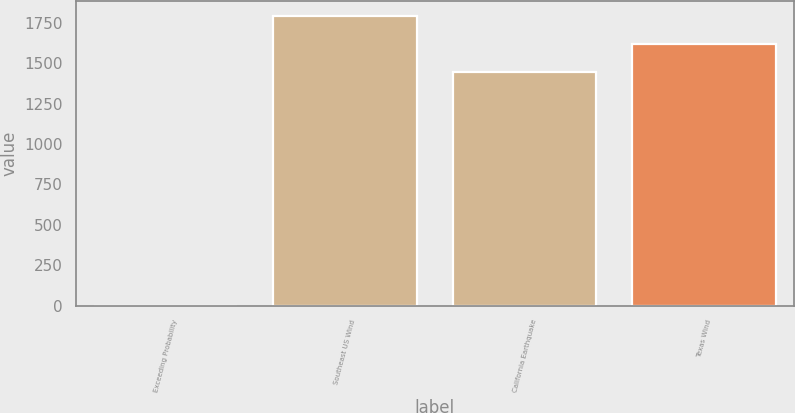Convert chart. <chart><loc_0><loc_0><loc_500><loc_500><bar_chart><fcel>Exceeding Probability<fcel>Southeast US Wind<fcel>California Earthquake<fcel>Texas Wind<nl><fcel>0.4<fcel>1793.92<fcel>1445<fcel>1619.46<nl></chart> 